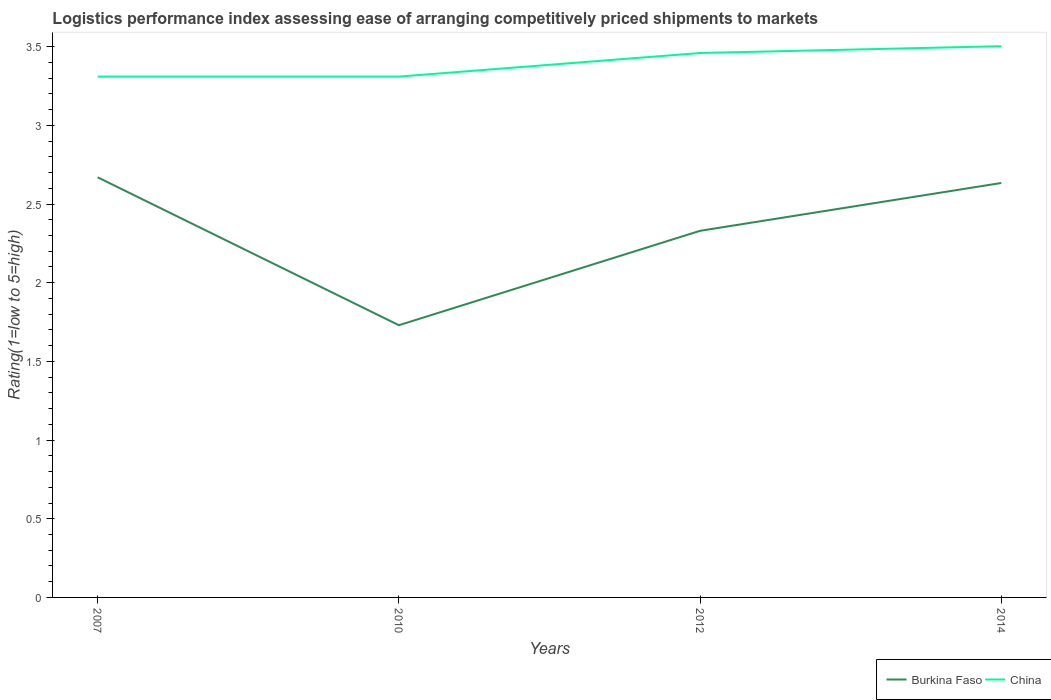How many different coloured lines are there?
Your answer should be compact. 2. Across all years, what is the maximum Logistic performance index in Burkina Faso?
Keep it short and to the point. 1.73. What is the total Logistic performance index in Burkina Faso in the graph?
Make the answer very short. 0.94. What is the difference between the highest and the second highest Logistic performance index in China?
Make the answer very short. 0.19. What is the difference between two consecutive major ticks on the Y-axis?
Provide a succinct answer. 0.5. Are the values on the major ticks of Y-axis written in scientific E-notation?
Give a very brief answer. No. Does the graph contain any zero values?
Offer a very short reply. No. Where does the legend appear in the graph?
Give a very brief answer. Bottom right. How many legend labels are there?
Your response must be concise. 2. What is the title of the graph?
Give a very brief answer. Logistics performance index assessing ease of arranging competitively priced shipments to markets. Does "Haiti" appear as one of the legend labels in the graph?
Make the answer very short. No. What is the label or title of the X-axis?
Offer a very short reply. Years. What is the label or title of the Y-axis?
Your answer should be very brief. Rating(1=low to 5=high). What is the Rating(1=low to 5=high) of Burkina Faso in 2007?
Offer a very short reply. 2.67. What is the Rating(1=low to 5=high) in China in 2007?
Make the answer very short. 3.31. What is the Rating(1=low to 5=high) of Burkina Faso in 2010?
Offer a very short reply. 1.73. What is the Rating(1=low to 5=high) in China in 2010?
Your response must be concise. 3.31. What is the Rating(1=low to 5=high) of Burkina Faso in 2012?
Provide a succinct answer. 2.33. What is the Rating(1=low to 5=high) of China in 2012?
Offer a very short reply. 3.46. What is the Rating(1=low to 5=high) in Burkina Faso in 2014?
Make the answer very short. 2.63. What is the Rating(1=low to 5=high) in China in 2014?
Provide a short and direct response. 3.5. Across all years, what is the maximum Rating(1=low to 5=high) of Burkina Faso?
Offer a very short reply. 2.67. Across all years, what is the maximum Rating(1=low to 5=high) in China?
Your answer should be compact. 3.5. Across all years, what is the minimum Rating(1=low to 5=high) of Burkina Faso?
Make the answer very short. 1.73. Across all years, what is the minimum Rating(1=low to 5=high) in China?
Provide a succinct answer. 3.31. What is the total Rating(1=low to 5=high) of Burkina Faso in the graph?
Provide a short and direct response. 9.36. What is the total Rating(1=low to 5=high) of China in the graph?
Make the answer very short. 13.58. What is the difference between the Rating(1=low to 5=high) of China in 2007 and that in 2010?
Ensure brevity in your answer.  0. What is the difference between the Rating(1=low to 5=high) in Burkina Faso in 2007 and that in 2012?
Offer a terse response. 0.34. What is the difference between the Rating(1=low to 5=high) in China in 2007 and that in 2012?
Offer a very short reply. -0.15. What is the difference between the Rating(1=low to 5=high) in Burkina Faso in 2007 and that in 2014?
Offer a very short reply. 0.04. What is the difference between the Rating(1=low to 5=high) in China in 2007 and that in 2014?
Make the answer very short. -0.19. What is the difference between the Rating(1=low to 5=high) of Burkina Faso in 2010 and that in 2014?
Offer a terse response. -0.9. What is the difference between the Rating(1=low to 5=high) of China in 2010 and that in 2014?
Give a very brief answer. -0.19. What is the difference between the Rating(1=low to 5=high) in Burkina Faso in 2012 and that in 2014?
Ensure brevity in your answer.  -0.3. What is the difference between the Rating(1=low to 5=high) of China in 2012 and that in 2014?
Provide a succinct answer. -0.04. What is the difference between the Rating(1=low to 5=high) of Burkina Faso in 2007 and the Rating(1=low to 5=high) of China in 2010?
Provide a succinct answer. -0.64. What is the difference between the Rating(1=low to 5=high) in Burkina Faso in 2007 and the Rating(1=low to 5=high) in China in 2012?
Offer a terse response. -0.79. What is the difference between the Rating(1=low to 5=high) of Burkina Faso in 2007 and the Rating(1=low to 5=high) of China in 2014?
Offer a very short reply. -0.83. What is the difference between the Rating(1=low to 5=high) in Burkina Faso in 2010 and the Rating(1=low to 5=high) in China in 2012?
Offer a terse response. -1.73. What is the difference between the Rating(1=low to 5=high) of Burkina Faso in 2010 and the Rating(1=low to 5=high) of China in 2014?
Provide a succinct answer. -1.77. What is the difference between the Rating(1=low to 5=high) in Burkina Faso in 2012 and the Rating(1=low to 5=high) in China in 2014?
Ensure brevity in your answer.  -1.17. What is the average Rating(1=low to 5=high) in Burkina Faso per year?
Give a very brief answer. 2.34. What is the average Rating(1=low to 5=high) of China per year?
Give a very brief answer. 3.4. In the year 2007, what is the difference between the Rating(1=low to 5=high) in Burkina Faso and Rating(1=low to 5=high) in China?
Your answer should be compact. -0.64. In the year 2010, what is the difference between the Rating(1=low to 5=high) in Burkina Faso and Rating(1=low to 5=high) in China?
Provide a short and direct response. -1.58. In the year 2012, what is the difference between the Rating(1=low to 5=high) of Burkina Faso and Rating(1=low to 5=high) of China?
Offer a very short reply. -1.13. In the year 2014, what is the difference between the Rating(1=low to 5=high) in Burkina Faso and Rating(1=low to 5=high) in China?
Your response must be concise. -0.87. What is the ratio of the Rating(1=low to 5=high) of Burkina Faso in 2007 to that in 2010?
Your answer should be compact. 1.54. What is the ratio of the Rating(1=low to 5=high) in China in 2007 to that in 2010?
Your answer should be very brief. 1. What is the ratio of the Rating(1=low to 5=high) of Burkina Faso in 2007 to that in 2012?
Your answer should be very brief. 1.15. What is the ratio of the Rating(1=low to 5=high) of China in 2007 to that in 2012?
Your response must be concise. 0.96. What is the ratio of the Rating(1=low to 5=high) in Burkina Faso in 2007 to that in 2014?
Give a very brief answer. 1.01. What is the ratio of the Rating(1=low to 5=high) in China in 2007 to that in 2014?
Your answer should be compact. 0.94. What is the ratio of the Rating(1=low to 5=high) of Burkina Faso in 2010 to that in 2012?
Provide a succinct answer. 0.74. What is the ratio of the Rating(1=low to 5=high) in China in 2010 to that in 2012?
Offer a very short reply. 0.96. What is the ratio of the Rating(1=low to 5=high) in Burkina Faso in 2010 to that in 2014?
Offer a very short reply. 0.66. What is the ratio of the Rating(1=low to 5=high) in China in 2010 to that in 2014?
Your answer should be very brief. 0.94. What is the ratio of the Rating(1=low to 5=high) of Burkina Faso in 2012 to that in 2014?
Provide a succinct answer. 0.88. What is the ratio of the Rating(1=low to 5=high) of China in 2012 to that in 2014?
Provide a short and direct response. 0.99. What is the difference between the highest and the second highest Rating(1=low to 5=high) of Burkina Faso?
Make the answer very short. 0.04. What is the difference between the highest and the second highest Rating(1=low to 5=high) of China?
Keep it short and to the point. 0.04. What is the difference between the highest and the lowest Rating(1=low to 5=high) in China?
Your response must be concise. 0.19. 